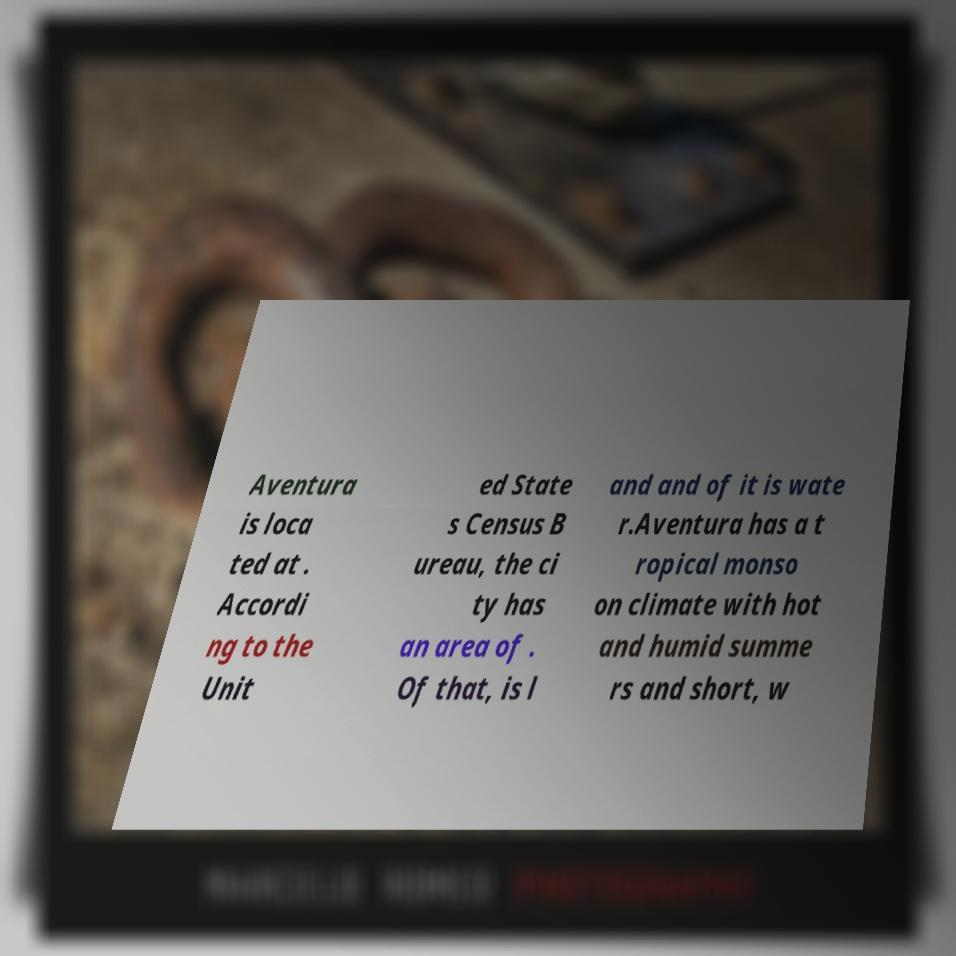I need the written content from this picture converted into text. Can you do that? Aventura is loca ted at . Accordi ng to the Unit ed State s Census B ureau, the ci ty has an area of . Of that, is l and and of it is wate r.Aventura has a t ropical monso on climate with hot and humid summe rs and short, w 